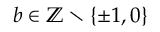<formula> <loc_0><loc_0><loc_500><loc_500>b \in \mathbb { Z } \ \{ \pm 1 , 0 \}</formula> 